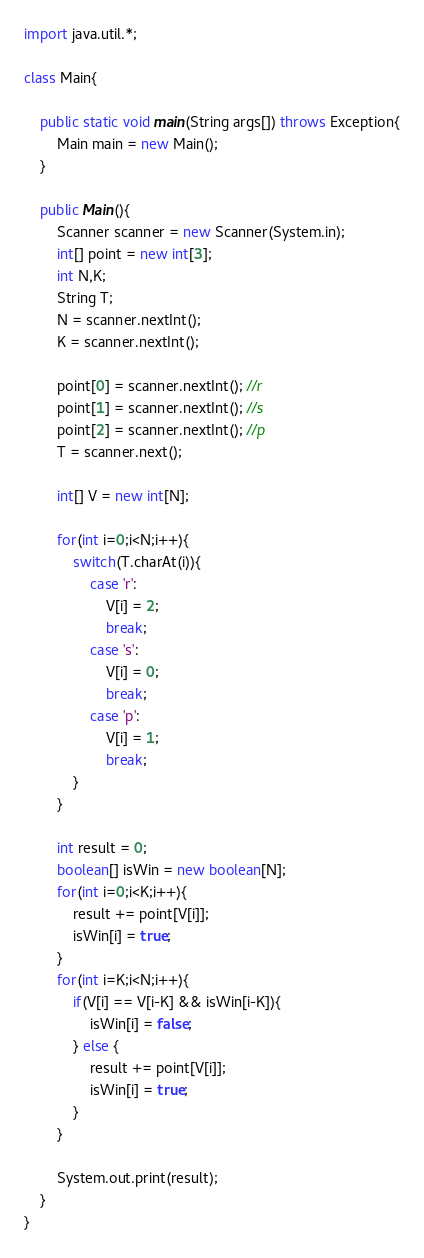Convert code to text. <code><loc_0><loc_0><loc_500><loc_500><_Java_>import java.util.*;

class Main{

    public static void main(String args[]) throws Exception{
        Main main = new Main();
    }

    public Main(){
        Scanner scanner = new Scanner(System.in);
        int[] point = new int[3];
        int N,K;
        String T;
        N = scanner.nextInt();
        K = scanner.nextInt();

        point[0] = scanner.nextInt(); //r
        point[1] = scanner.nextInt(); //s
        point[2] = scanner.nextInt(); //p
        T = scanner.next();

        int[] V = new int[N];

        for(int i=0;i<N;i++){
            switch(T.charAt(i)){
                case 'r':
                    V[i] = 2;
                    break;
                case 's':
                    V[i] = 0;
                    break;
                case 'p':
                    V[i] = 1;
                    break;
            }
        }

        int result = 0;
        boolean[] isWin = new boolean[N];
        for(int i=0;i<K;i++){
            result += point[V[i]];
            isWin[i] = true;
        }
        for(int i=K;i<N;i++){
            if(V[i] == V[i-K] && isWin[i-K]){
                isWin[i] = false;
            } else {
                result += point[V[i]];
                isWin[i] = true;
            }
        }

        System.out.print(result);
    }
}
</code> 